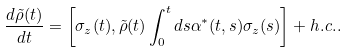Convert formula to latex. <formula><loc_0><loc_0><loc_500><loc_500>\frac { d \tilde { \rho } ( t ) } { d t } = \left [ \sigma _ { z } ( t ) , \tilde { \rho } ( t ) \int _ { 0 } ^ { t } d s \alpha ^ { * } ( t , s ) \sigma _ { z } ( s ) \right ] + h . c . .</formula> 